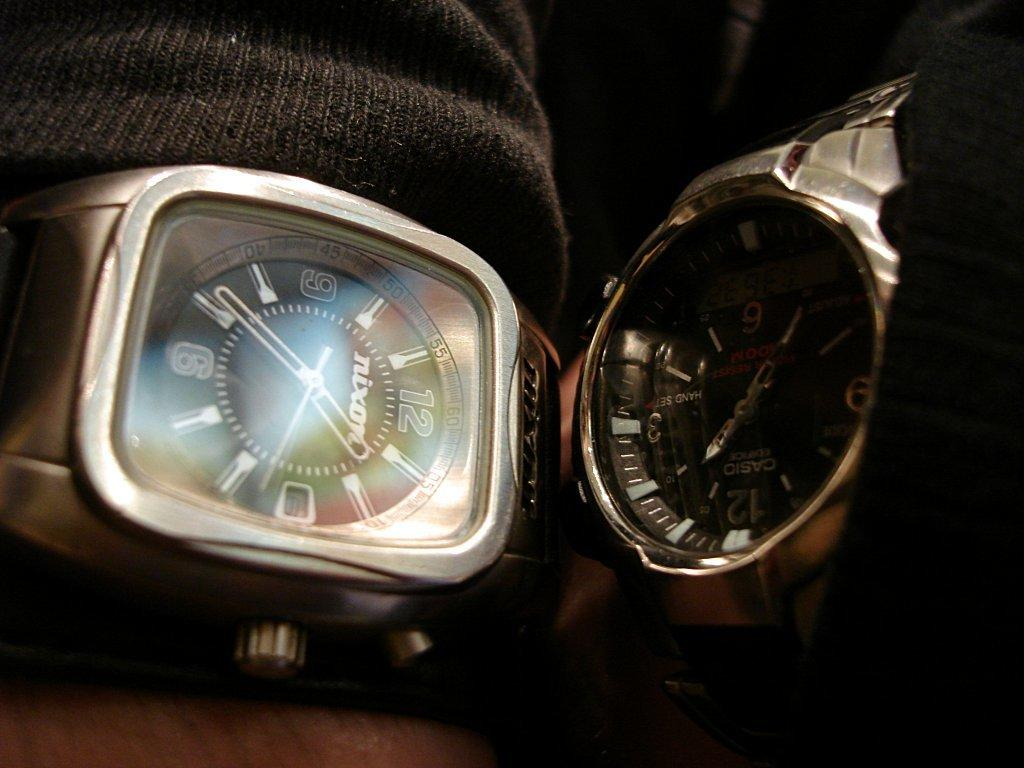<image>
Render a clear and concise summary of the photo. Two watches next to each other and the square faced one is a nixon 